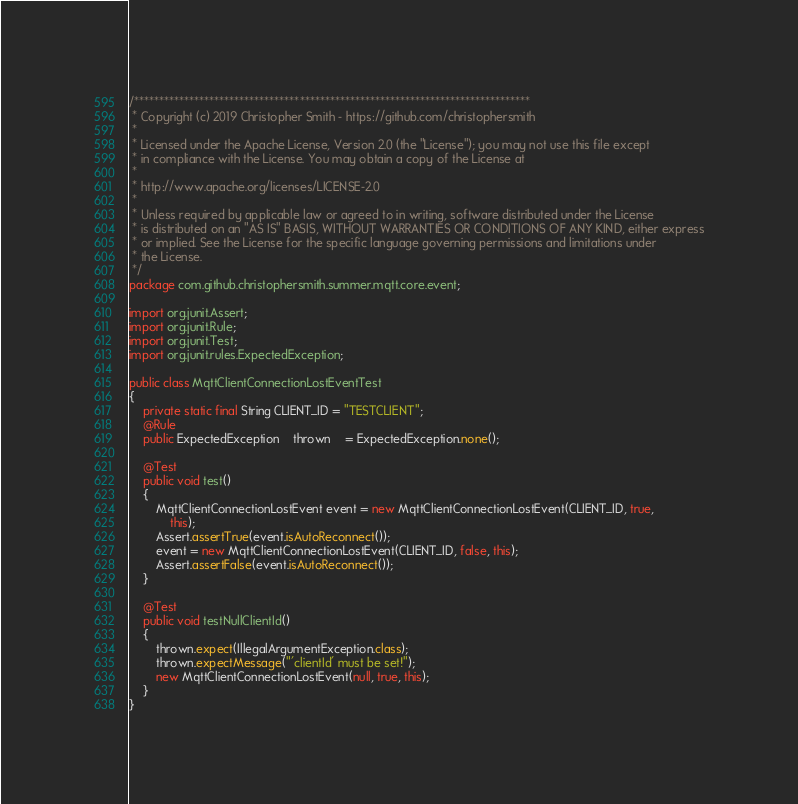<code> <loc_0><loc_0><loc_500><loc_500><_Java_>/*******************************************************************************
 * Copyright (c) 2019 Christopher Smith - https://github.com/christophersmith
 * 
 * Licensed under the Apache License, Version 2.0 (the "License"); you may not use this file except
 * in compliance with the License. You may obtain a copy of the License at
 * 
 * http://www.apache.org/licenses/LICENSE-2.0
 * 
 * Unless required by applicable law or agreed to in writing, software distributed under the License
 * is distributed on an "AS IS" BASIS, WITHOUT WARRANTIES OR CONDITIONS OF ANY KIND, either express
 * or implied. See the License for the specific language governing permissions and limitations under
 * the License.
 */
package com.github.christophersmith.summer.mqtt.core.event;

import org.junit.Assert;
import org.junit.Rule;
import org.junit.Test;
import org.junit.rules.ExpectedException;

public class MqttClientConnectionLostEventTest
{
    private static final String CLIENT_ID = "TESTCLIENT";
    @Rule
    public ExpectedException    thrown    = ExpectedException.none();

    @Test
    public void test()
    {
        MqttClientConnectionLostEvent event = new MqttClientConnectionLostEvent(CLIENT_ID, true,
            this);
        Assert.assertTrue(event.isAutoReconnect());
        event = new MqttClientConnectionLostEvent(CLIENT_ID, false, this);
        Assert.assertFalse(event.isAutoReconnect());
    }

    @Test
    public void testNullClientId()
    {
        thrown.expect(IllegalArgumentException.class);
        thrown.expectMessage("'clientId' must be set!");
        new MqttClientConnectionLostEvent(null, true, this);
    }
}
</code> 